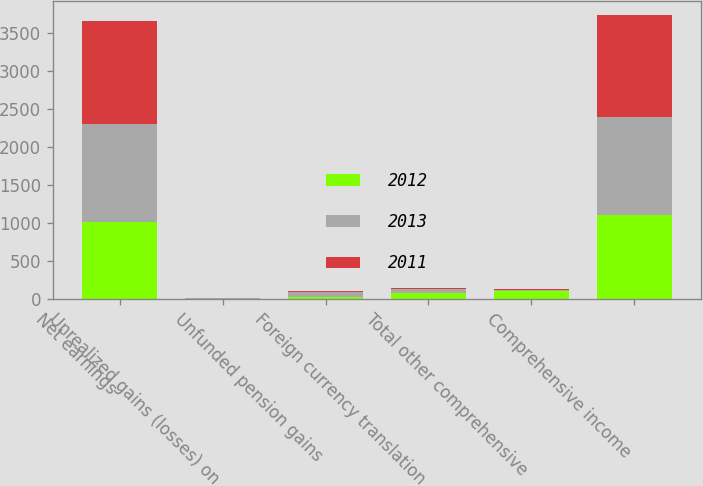Convert chart to OTSL. <chart><loc_0><loc_0><loc_500><loc_500><stacked_bar_chart><ecel><fcel>Net earnings<fcel>Unrealized gains (losses) on<fcel>Unfunded pension gains<fcel>Foreign currency translation<fcel>Total other comprehensive<fcel>Comprehensive income<nl><fcel>2012<fcel>1006<fcel>4<fcel>20<fcel>80<fcel>103<fcel>1109<nl><fcel>2013<fcel>1298<fcel>4<fcel>69<fcel>50<fcel>15<fcel>1283<nl><fcel>2011<fcel>1345<fcel>2<fcel>12<fcel>20<fcel>10<fcel>1335<nl></chart> 